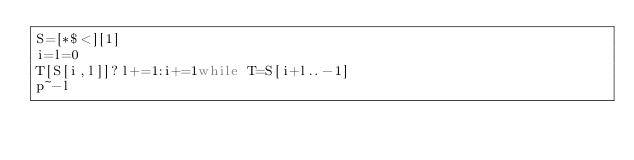Convert code to text. <code><loc_0><loc_0><loc_500><loc_500><_Ruby_>S=[*$<][1]
i=l=0
T[S[i,l]]?l+=1:i+=1while T=S[i+l..-1]
p~-l</code> 